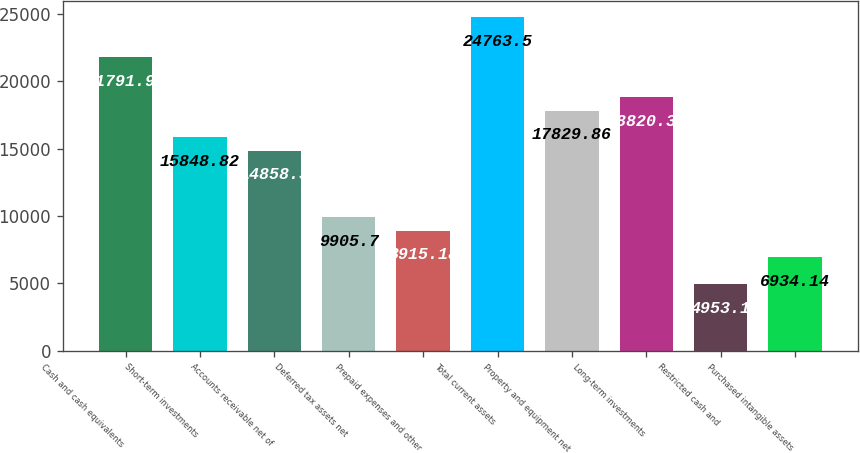<chart> <loc_0><loc_0><loc_500><loc_500><bar_chart><fcel>Cash and cash equivalents<fcel>Short-term investments<fcel>Accounts receivable net of<fcel>Deferred tax assets net<fcel>Prepaid expenses and other<fcel>Total current assets<fcel>Property and equipment net<fcel>Long-term investments<fcel>Restricted cash and<fcel>Purchased intangible assets<nl><fcel>21791.9<fcel>15848.8<fcel>14858.3<fcel>9905.7<fcel>8915.18<fcel>24763.5<fcel>17829.9<fcel>18820.4<fcel>4953.1<fcel>6934.14<nl></chart> 